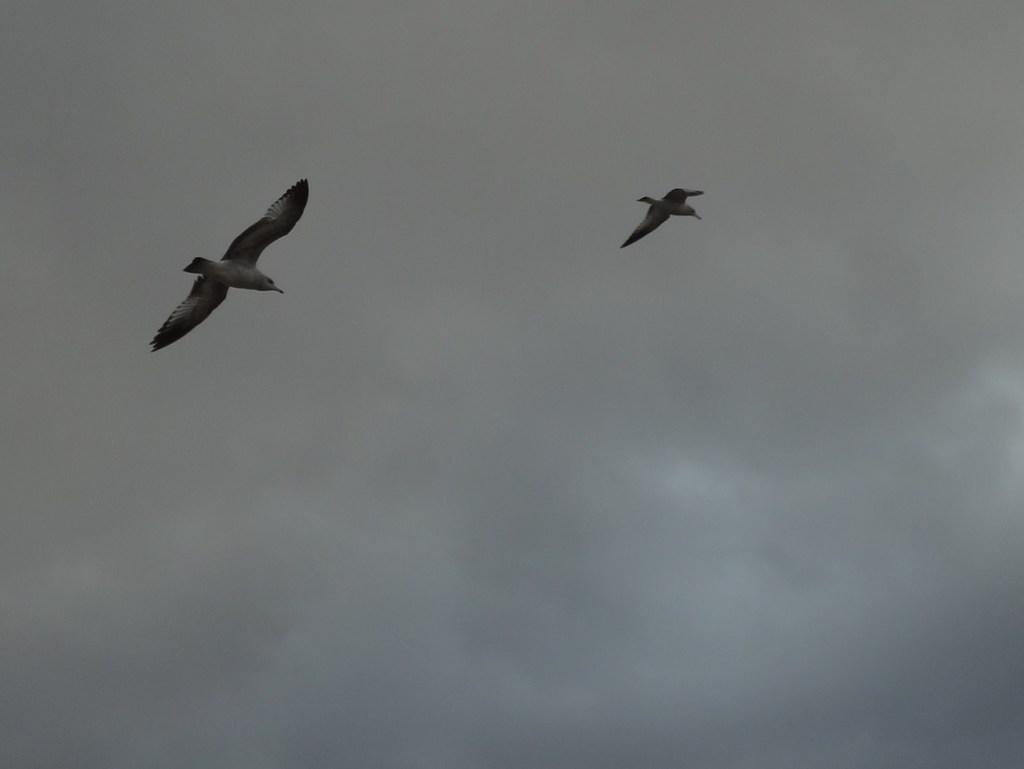Describe this image in one or two sentences. This image consists of two birds flying in the air. In the background, we can see the clouds in the sky. 